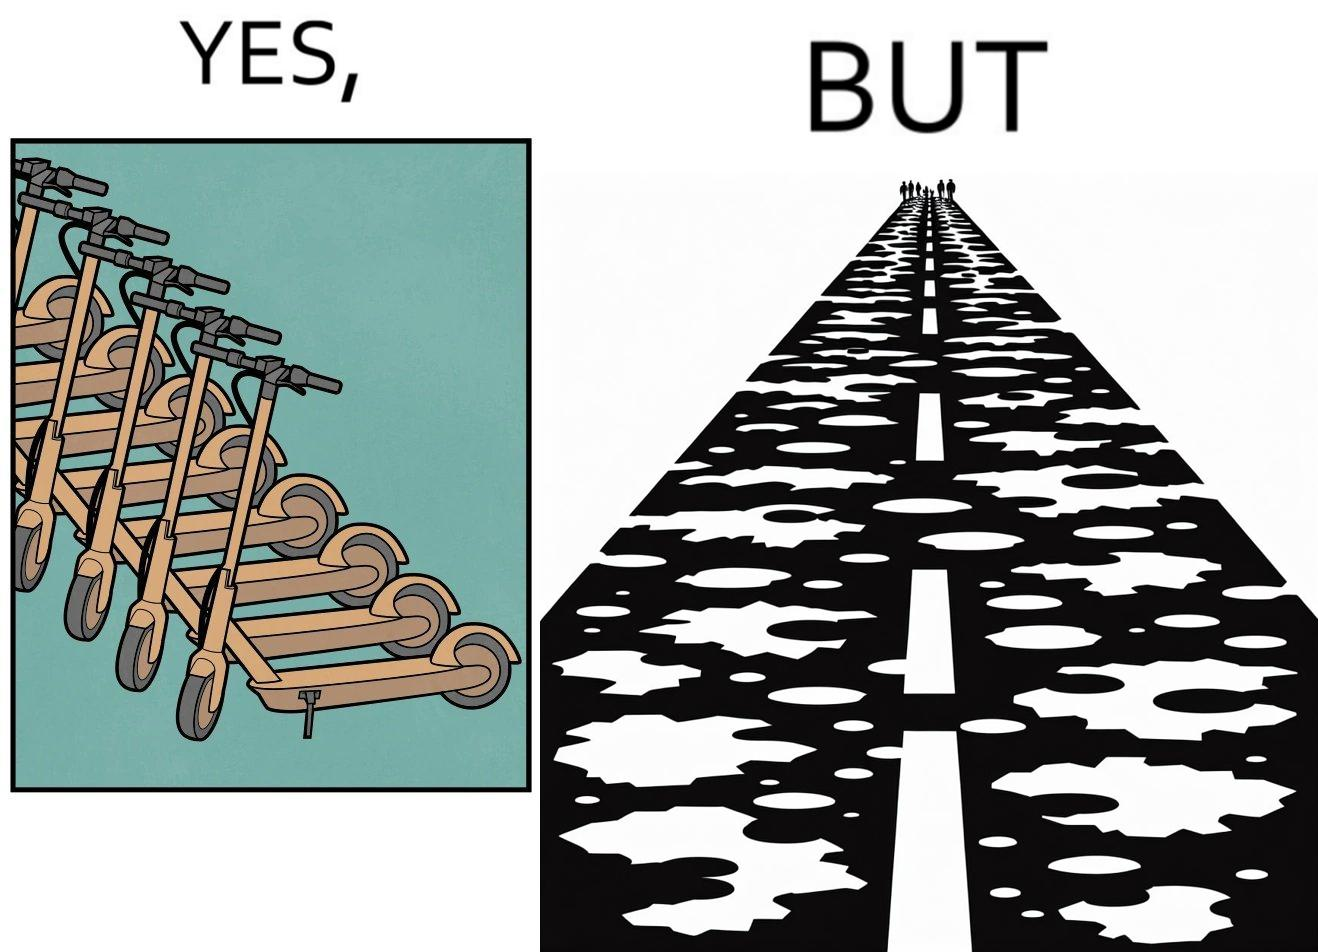What is shown in this image? The image is ironic, because even after when the skateboard scooters are available for someone to ride but the road has many potholes that it is not suitable to ride the scooters on such roads 